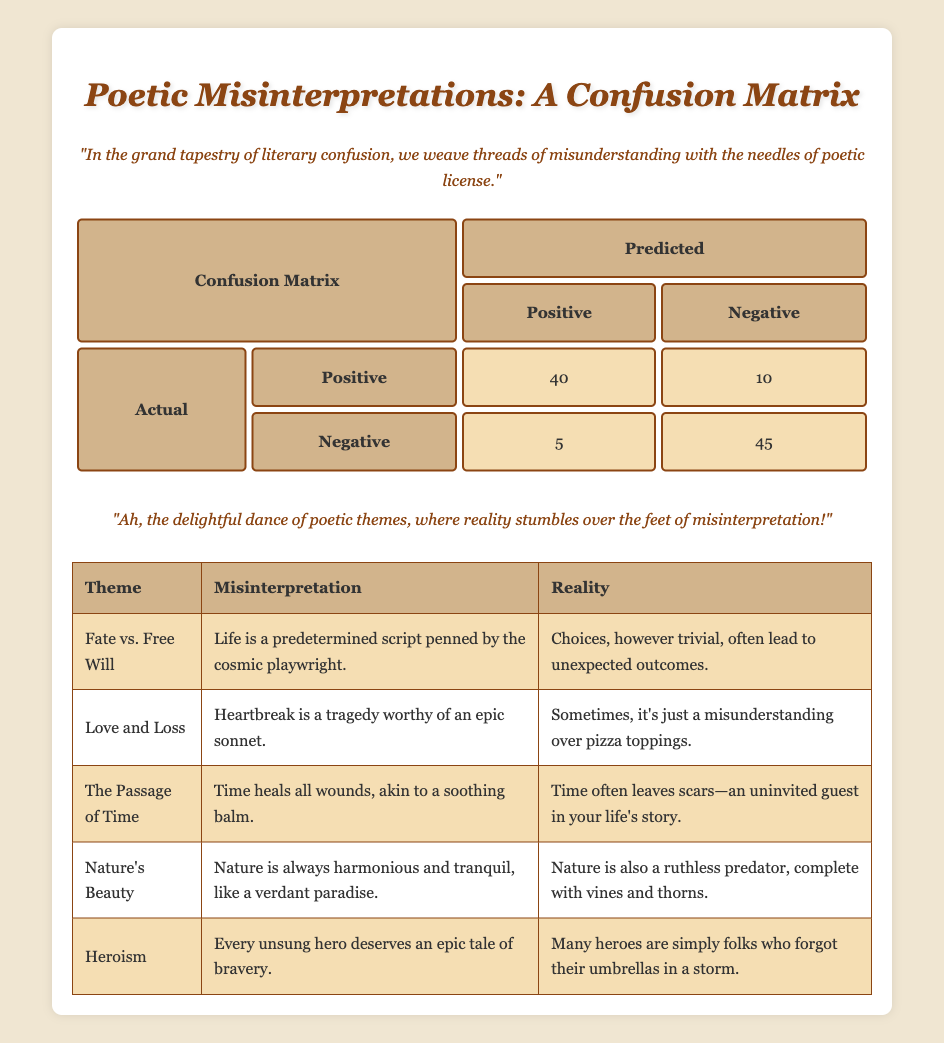What is the total number of actual positives? The total number of actual positives is found by adding the counts of those classified as positive and those classified as negative in the actual positive row. So, 40 (classified as positive) + 10 (classified as negative) = 50.
Answer: 50 What is the total number of classified negatives? To find the total number classified as negative, we add the counts from the classified as negative column. This includes those classified as negative from both the actual positive and actual negative rows: 10 (from actual positive) + 45 (from actual negative) = 55.
Answer: 55 How many actual negatives were misclassified as positives? The count of actual negatives misclassified as positives can be directly extracted from the confusion matrix, which shows 5 classified as positive from the actual negative row.
Answer: 5 What percentage of the actual positives were correctly classified? To find the percentage of actual positives that were correctly classified, we divide the number of true positives (40) by the total actual positives (50), then multiply by 100: (40/50) * 100 = 80%.
Answer: 80% Is it true that there were more actual positives than actual negatives? We determine this by comparing the total counts: actual positives = 50 and actual negatives = 50 (5 from classified as positive and 45 from classified as negative). Since they are equal, the statement is false.
Answer: False What is the overall accuracy of the classification? To calculate overall accuracy, we sum all correct classifications (true positives and true negatives) and divide by the total number of instances. Here, that means (40 + 45) / (40 + 10 + 5 + 45) = 85 / 100 = 0.85, or 85%.
Answer: 85% What is the difference between the number of actual positives and the number of actual negatives? We first find the total actual positives (50) and the total actual negatives (50). The difference is calculated by subtracting one from the other: 50 - 50 = 0.
Answer: 0 How often were actual positives classified as negatives compared to actual negatives classified as positives? To find this, we assess the counts: 10 actual positives were classified as negatives, while 5 actual negatives were misclassified as positives. The ratio is thus 10:5, simplified to 2:1.
Answer: 2:1 